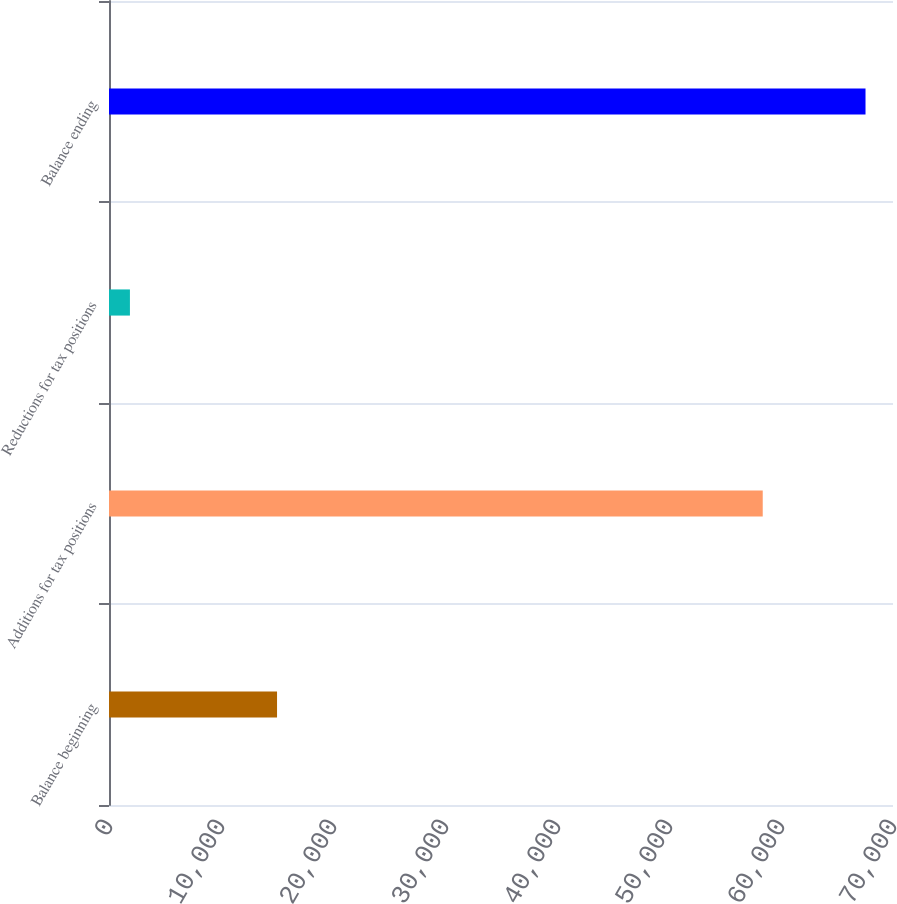Convert chart. <chart><loc_0><loc_0><loc_500><loc_500><bar_chart><fcel>Balance beginning<fcel>Additions for tax positions<fcel>Reductions for tax positions<fcel>Balance ending<nl><fcel>15003.6<fcel>58369<fcel>1868<fcel>67546<nl></chart> 